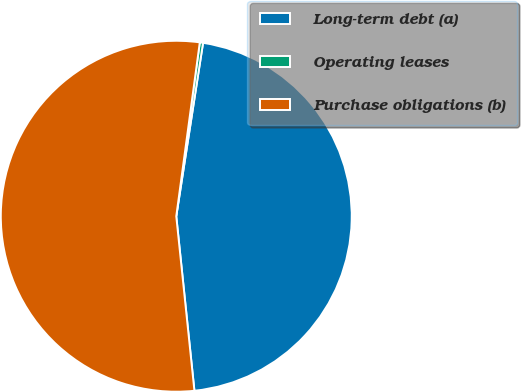Convert chart. <chart><loc_0><loc_0><loc_500><loc_500><pie_chart><fcel>Long-term debt (a)<fcel>Operating leases<fcel>Purchase obligations (b)<nl><fcel>45.91%<fcel>0.3%<fcel>53.79%<nl></chart> 